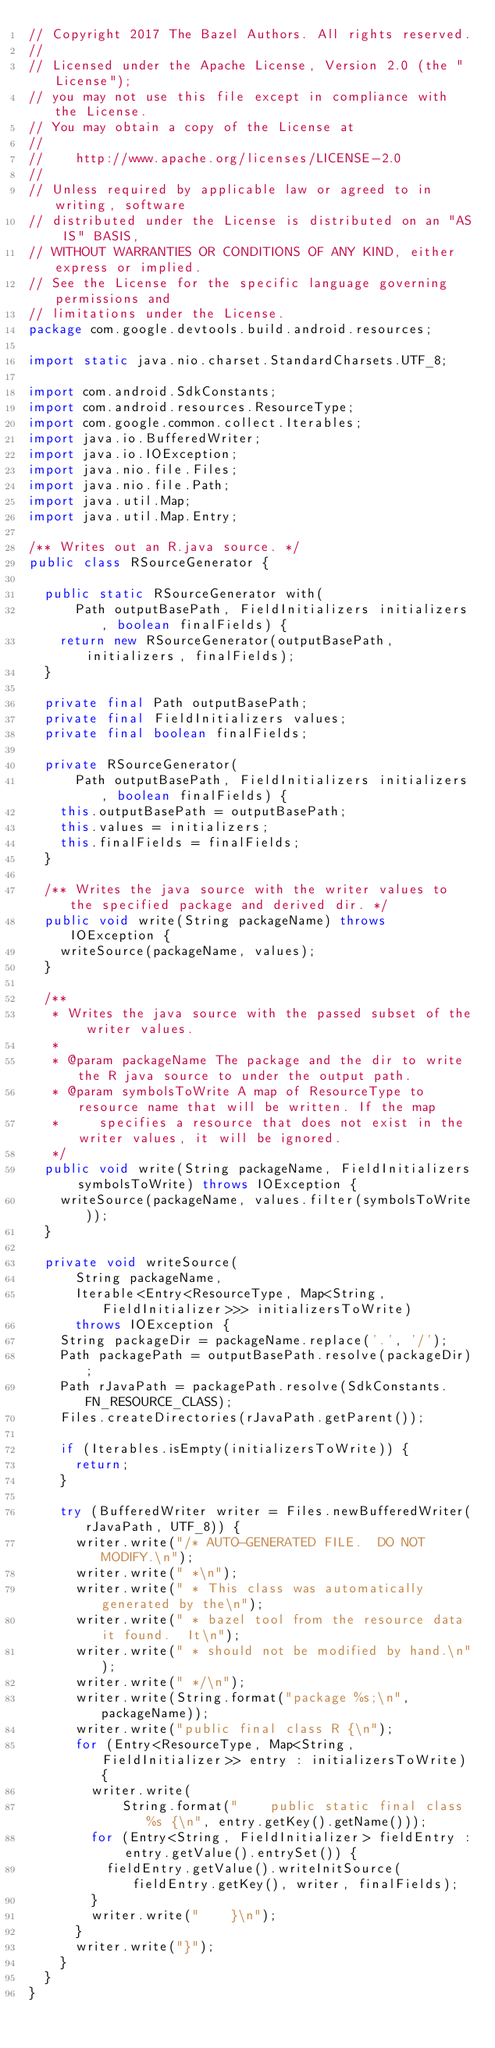Convert code to text. <code><loc_0><loc_0><loc_500><loc_500><_Java_>// Copyright 2017 The Bazel Authors. All rights reserved.
//
// Licensed under the Apache License, Version 2.0 (the "License");
// you may not use this file except in compliance with the License.
// You may obtain a copy of the License at
//
//    http://www.apache.org/licenses/LICENSE-2.0
//
// Unless required by applicable law or agreed to in writing, software
// distributed under the License is distributed on an "AS IS" BASIS,
// WITHOUT WARRANTIES OR CONDITIONS OF ANY KIND, either express or implied.
// See the License for the specific language governing permissions and
// limitations under the License.
package com.google.devtools.build.android.resources;

import static java.nio.charset.StandardCharsets.UTF_8;

import com.android.SdkConstants;
import com.android.resources.ResourceType;
import com.google.common.collect.Iterables;
import java.io.BufferedWriter;
import java.io.IOException;
import java.nio.file.Files;
import java.nio.file.Path;
import java.util.Map;
import java.util.Map.Entry;

/** Writes out an R.java source. */
public class RSourceGenerator {

  public static RSourceGenerator with(
      Path outputBasePath, FieldInitializers initializers, boolean finalFields) {
    return new RSourceGenerator(outputBasePath, initializers, finalFields);
  }

  private final Path outputBasePath;
  private final FieldInitializers values;
  private final boolean finalFields;

  private RSourceGenerator(
      Path outputBasePath, FieldInitializers initializers, boolean finalFields) {
    this.outputBasePath = outputBasePath;
    this.values = initializers;
    this.finalFields = finalFields;
  }

  /** Writes the java source with the writer values to the specified package and derived dir. */
  public void write(String packageName) throws IOException {
    writeSource(packageName, values);
  }

  /**
   * Writes the java source with the passed subset of the writer values.
   *
   * @param packageName The package and the dir to write the R java source to under the output path.
   * @param symbolsToWrite A map of ResourceType to resource name that will be written. If the map
   *     specifies a resource that does not exist in the writer values, it will be ignored.
   */
  public void write(String packageName, FieldInitializers symbolsToWrite) throws IOException {
    writeSource(packageName, values.filter(symbolsToWrite));
  }

  private void writeSource(
      String packageName,
      Iterable<Entry<ResourceType, Map<String, FieldInitializer>>> initializersToWrite)
      throws IOException {
    String packageDir = packageName.replace('.', '/');
    Path packagePath = outputBasePath.resolve(packageDir);
    Path rJavaPath = packagePath.resolve(SdkConstants.FN_RESOURCE_CLASS);
    Files.createDirectories(rJavaPath.getParent());

    if (Iterables.isEmpty(initializersToWrite)) {
      return;
    }

    try (BufferedWriter writer = Files.newBufferedWriter(rJavaPath, UTF_8)) {
      writer.write("/* AUTO-GENERATED FILE.  DO NOT MODIFY.\n");
      writer.write(" *\n");
      writer.write(" * This class was automatically generated by the\n");
      writer.write(" * bazel tool from the resource data it found.  It\n");
      writer.write(" * should not be modified by hand.\n");
      writer.write(" */\n");
      writer.write(String.format("package %s;\n", packageName));
      writer.write("public final class R {\n");
      for (Entry<ResourceType, Map<String, FieldInitializer>> entry : initializersToWrite) {
        writer.write(
            String.format("    public static final class %s {\n", entry.getKey().getName()));
        for (Entry<String, FieldInitializer> fieldEntry : entry.getValue().entrySet()) {
          fieldEntry.getValue().writeInitSource(fieldEntry.getKey(), writer, finalFields);
        }
        writer.write("    }\n");
      }
      writer.write("}");
    }
  }
}
</code> 